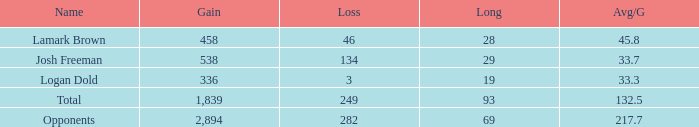How much Gain has a Long of 29, and an Avg/G smaller than 33.7? 0.0. 